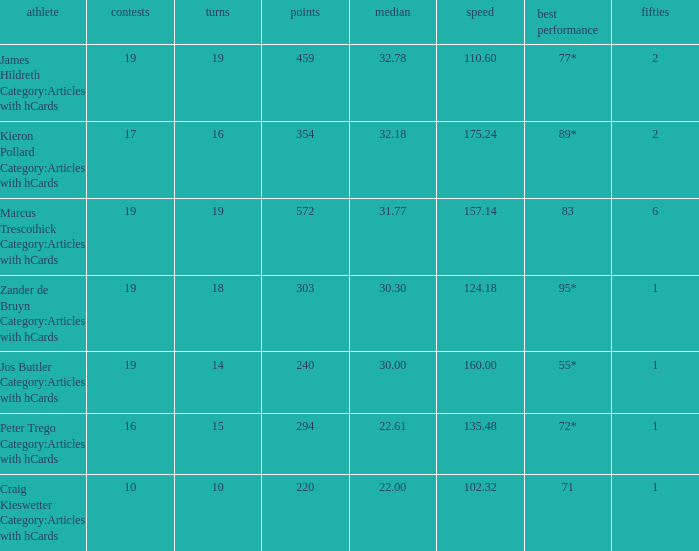What is the strike rate for the player with an average of 32.78? 110.6. 